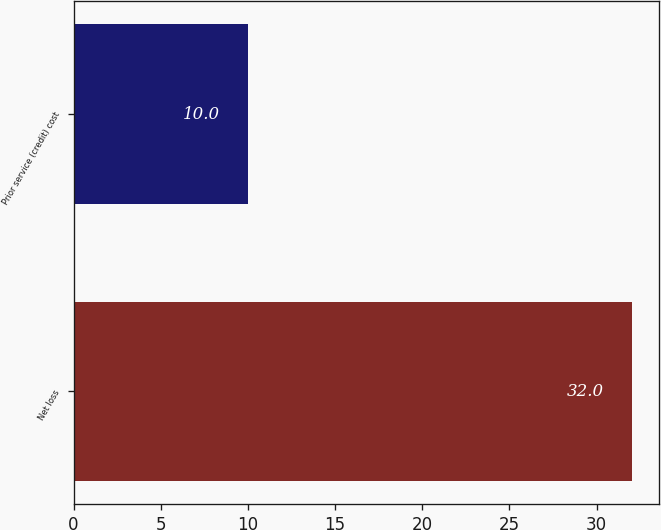Convert chart to OTSL. <chart><loc_0><loc_0><loc_500><loc_500><bar_chart><fcel>Net loss<fcel>Prior service (credit) cost<nl><fcel>32<fcel>10<nl></chart> 